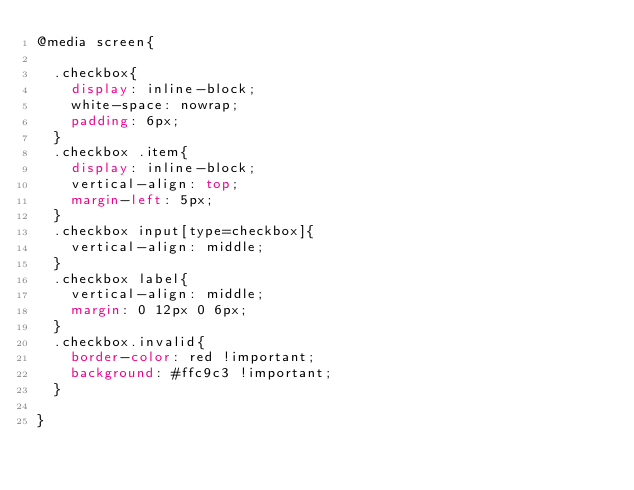<code> <loc_0><loc_0><loc_500><loc_500><_CSS_>@media screen{

  .checkbox{
    display: inline-block;
    white-space: nowrap;
    padding: 6px;
  }
  .checkbox .item{
    display: inline-block;
    vertical-align: top;
    margin-left: 5px;
  }
  .checkbox input[type=checkbox]{
    vertical-align: middle;
  }
  .checkbox label{
    vertical-align: middle;
    margin: 0 12px 0 6px;
  }
  .checkbox.invalid{
    border-color: red !important;
    background: #ffc9c3 !important;
  }

}</code> 